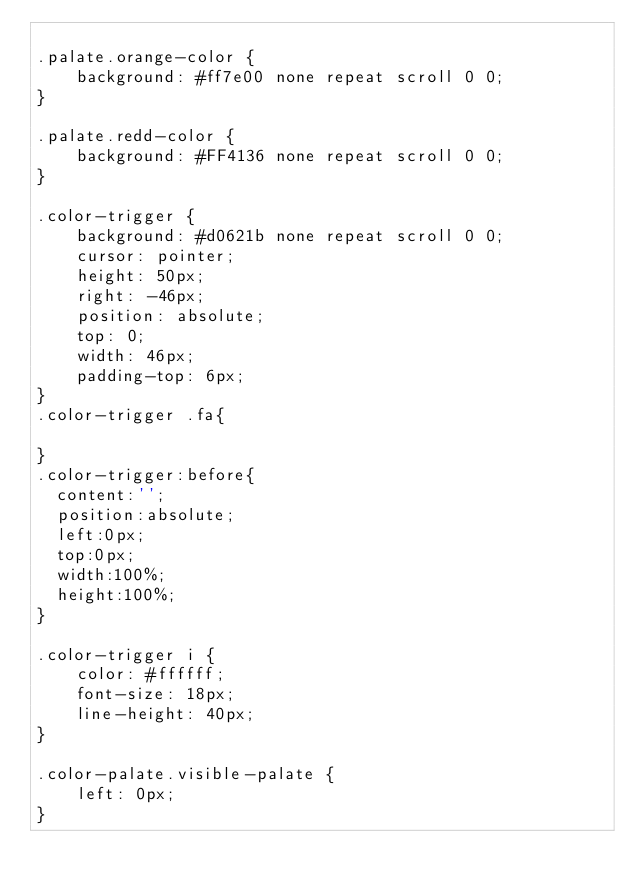<code> <loc_0><loc_0><loc_500><loc_500><_CSS_>
.palate.orange-color {
    background: #ff7e00 none repeat scroll 0 0;
}

.palate.redd-color {
    background: #FF4136 none repeat scroll 0 0;
}

.color-trigger {
    background: #d0621b none repeat scroll 0 0;
    cursor: pointer;
    height: 50px;
    right: -46px;
    position: absolute;
    top: 0;
    width: 46px;
    padding-top: 6px;
}
.color-trigger .fa{
	
}
.color-trigger:before{
	content:'';
	position:absolute;
	left:0px;
	top:0px;
	width:100%;
	height:100%;
}

.color-trigger i {
    color: #ffffff;
    font-size: 18px;
    line-height: 40px;
}

.color-palate.visible-palate {
    left: 0px;
}</code> 